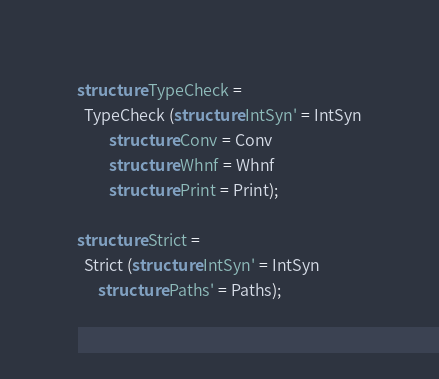<code> <loc_0><loc_0><loc_500><loc_500><_SML_>structure TypeCheck =
  TypeCheck (structure IntSyn' = IntSyn
	     structure Conv = Conv
	     structure Whnf = Whnf
	     structure Print = Print);

structure Strict =
  Strict (structure IntSyn' = IntSyn
	  structure Paths' = Paths);
</code> 